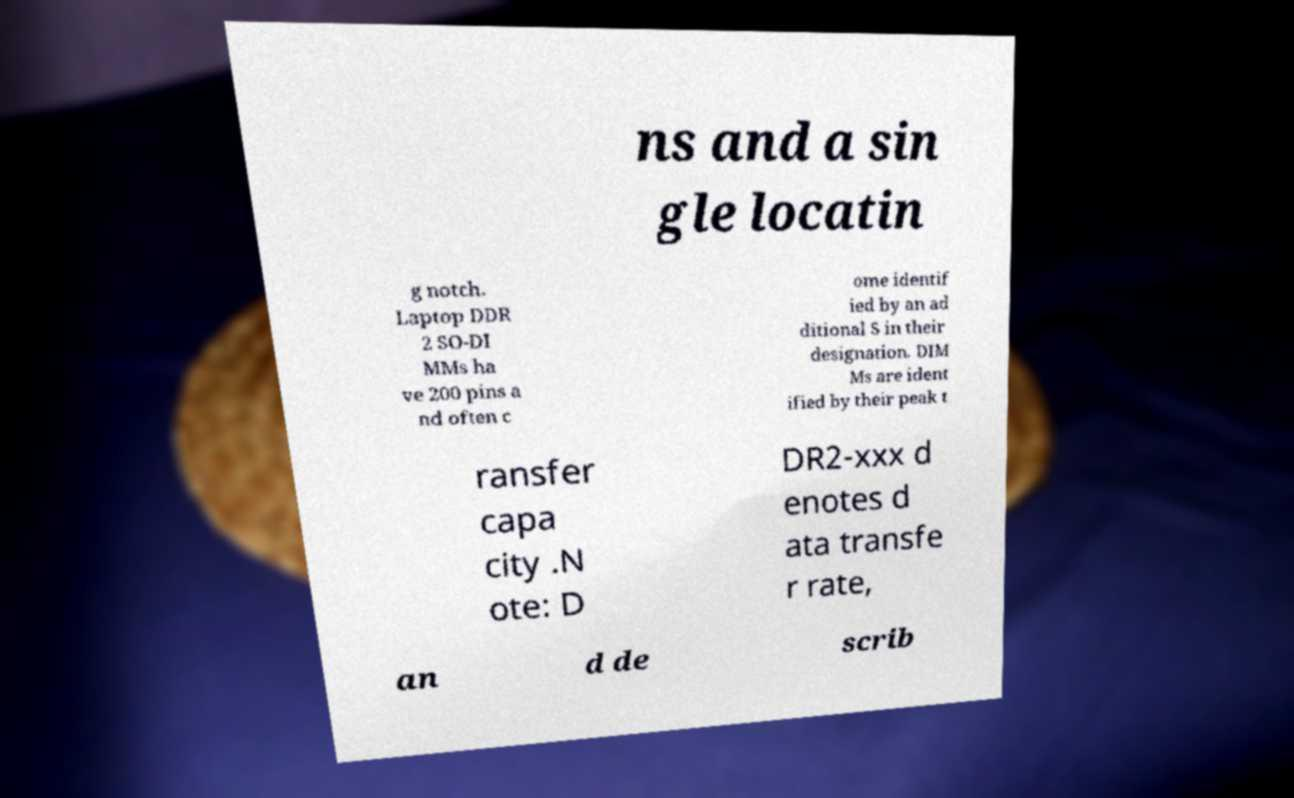Could you extract and type out the text from this image? ns and a sin gle locatin g notch. Laptop DDR 2 SO-DI MMs ha ve 200 pins a nd often c ome identif ied by an ad ditional S in their designation. DIM Ms are ident ified by their peak t ransfer capa city .N ote: D DR2-xxx d enotes d ata transfe r rate, an d de scrib 